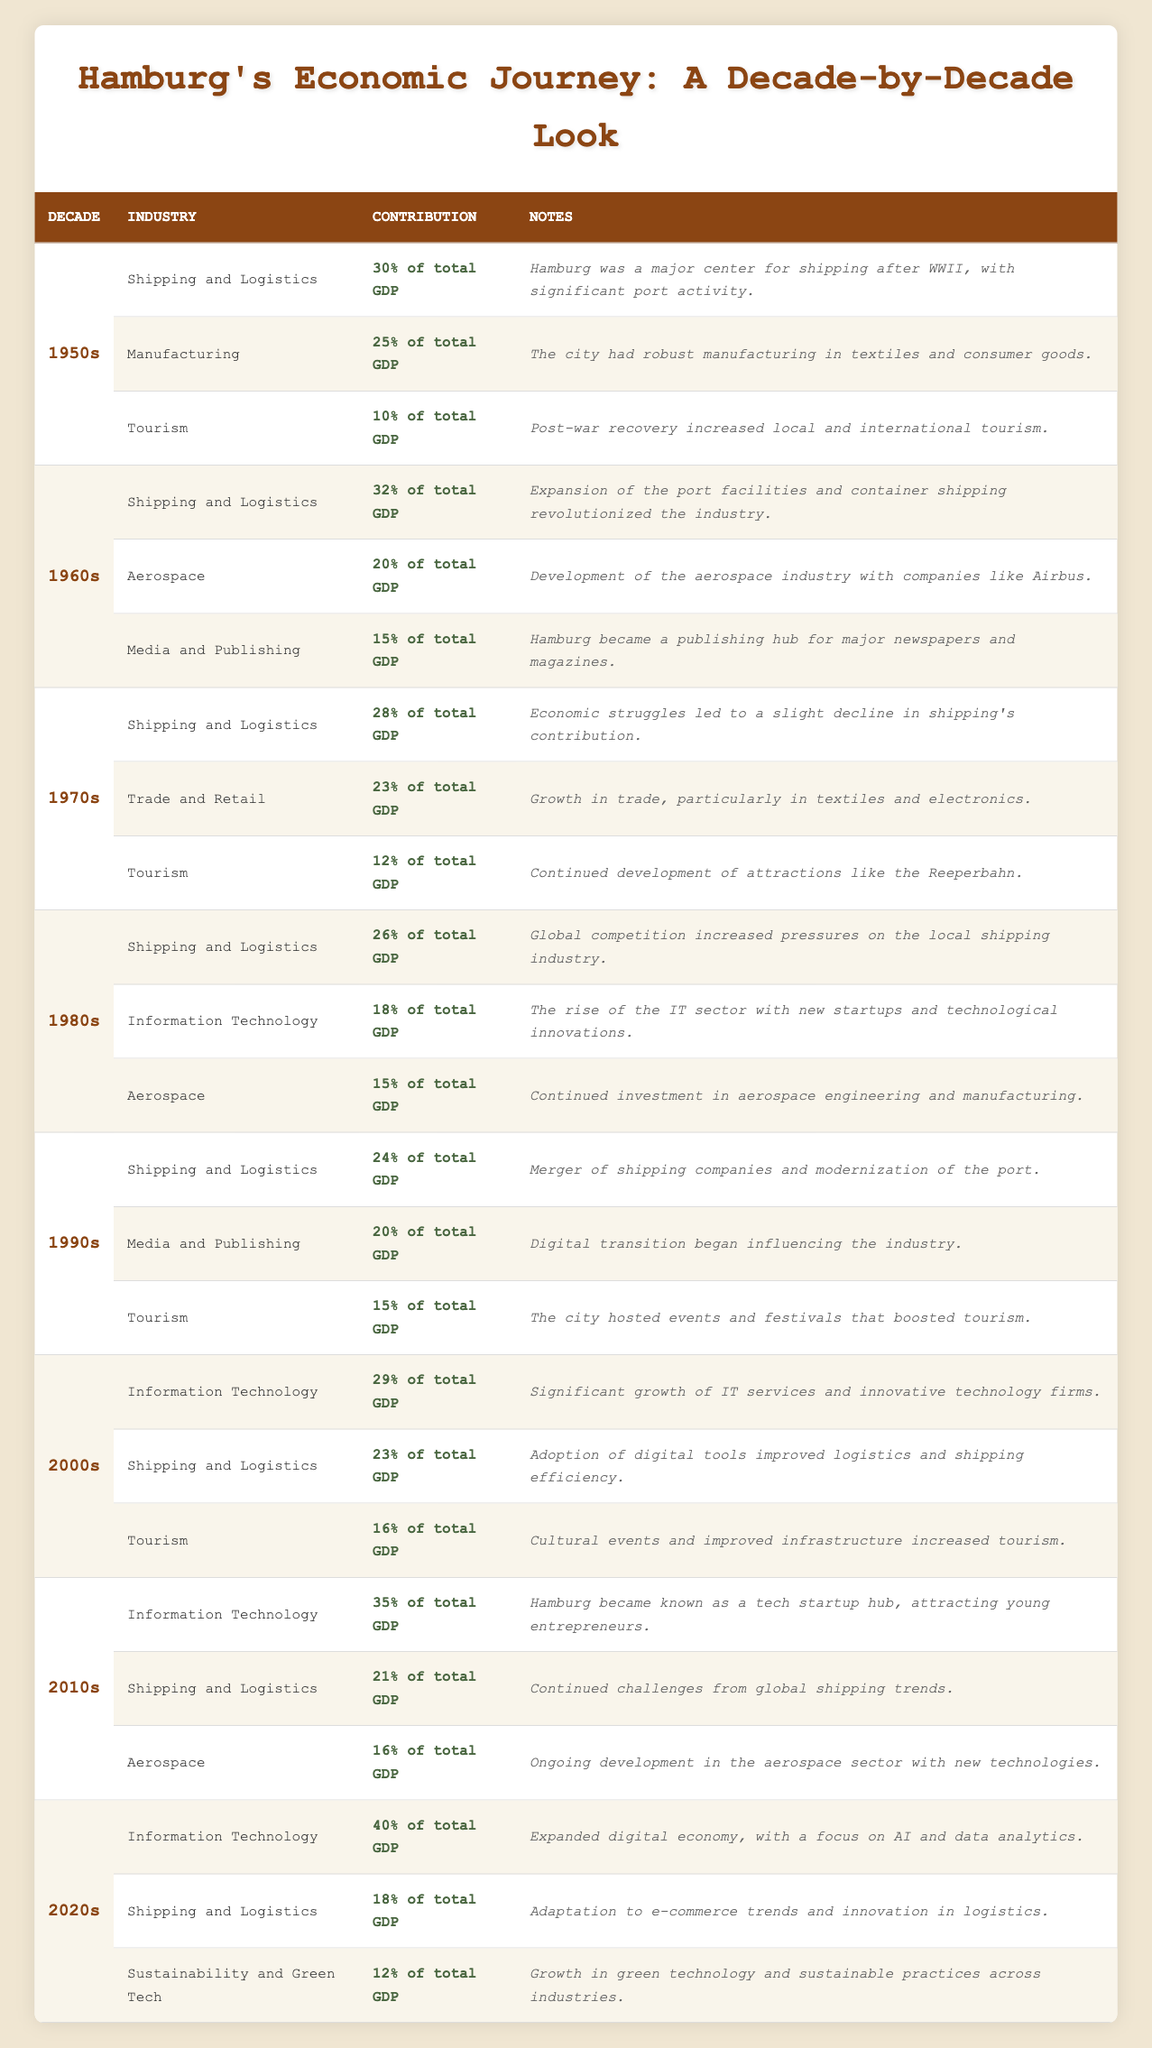What was the contribution of the Shipping and Logistics industry in the 1960s? From the data, under the decade of the 1960s, the contribution of the Shipping and Logistics industry is listed as 32% of total GDP.
Answer: 32% of total GDP Which decade saw the highest contribution from Information Technology? Reviewing the table, the contribution of Information Technology peaked in the 2020s at 40% of total GDP.
Answer: 2020s at 40% of total GDP Did Trade and Retail contribute more than Tourism in the 1970s? In the 1970s, Trade and Retail contributed 23% of total GDP while Tourism contributed 12%. Since 23% is greater than 12%, the answer is yes.
Answer: Yes What were the total contributions of the three major industries in the 1990s? The contributions in the 1990s were: Shipping and Logistics (24%), Media and Publishing (20%), and Tourism (15%). Summing these gives 24 + 20 + 15 = 59%.
Answer: 59% What was the change in contribution percentage for Shipping and Logistics from the 1950s to the 2020s? The contribution of Shipping and Logistics in the 1950s was 30% and in the 2020s it was 18%. The change is calculated as 30% - 18% = 12%.
Answer: 12% Which industry had the lowest contribution in the 2000s? In the 2000s, the contributions were: Information Technology (29%), Shipping and Logistics (23%), and Tourism (16%). The lowest contribution among these is from Tourism at 16%.
Answer: Tourism at 16% Was there an increase in the contribution of Tourism from the 1970s to the 1980s? In the 1970s, Tourism contributed 12% of total GDP while in the 1980s it contributed 15%. Since 15% is greater than 12%, there was an increase.
Answer: Yes What is the difference between the contributions of Information Technology in the 2010s and the 1990s? The contribution of Information Technology in the 2010s was 35%, while in the 1990s there was no specific data for IT, but Media and Publishing contributed 20%. Hence, the difference cannot be calculated in a traditional sense since they are different industries. This illustrates that no direct comparison can be made.
Answer: Not applicable What was the contribution of Aerospace in the 1980s compared to the 2010s? In the 1980s, Aerospace contributed 15% of total GDP, while in the 2010s it contributed 16%. Therefore, there was a slight increase in contribution from 15% to 16% in the 2010s.
Answer: Increased by 1% 